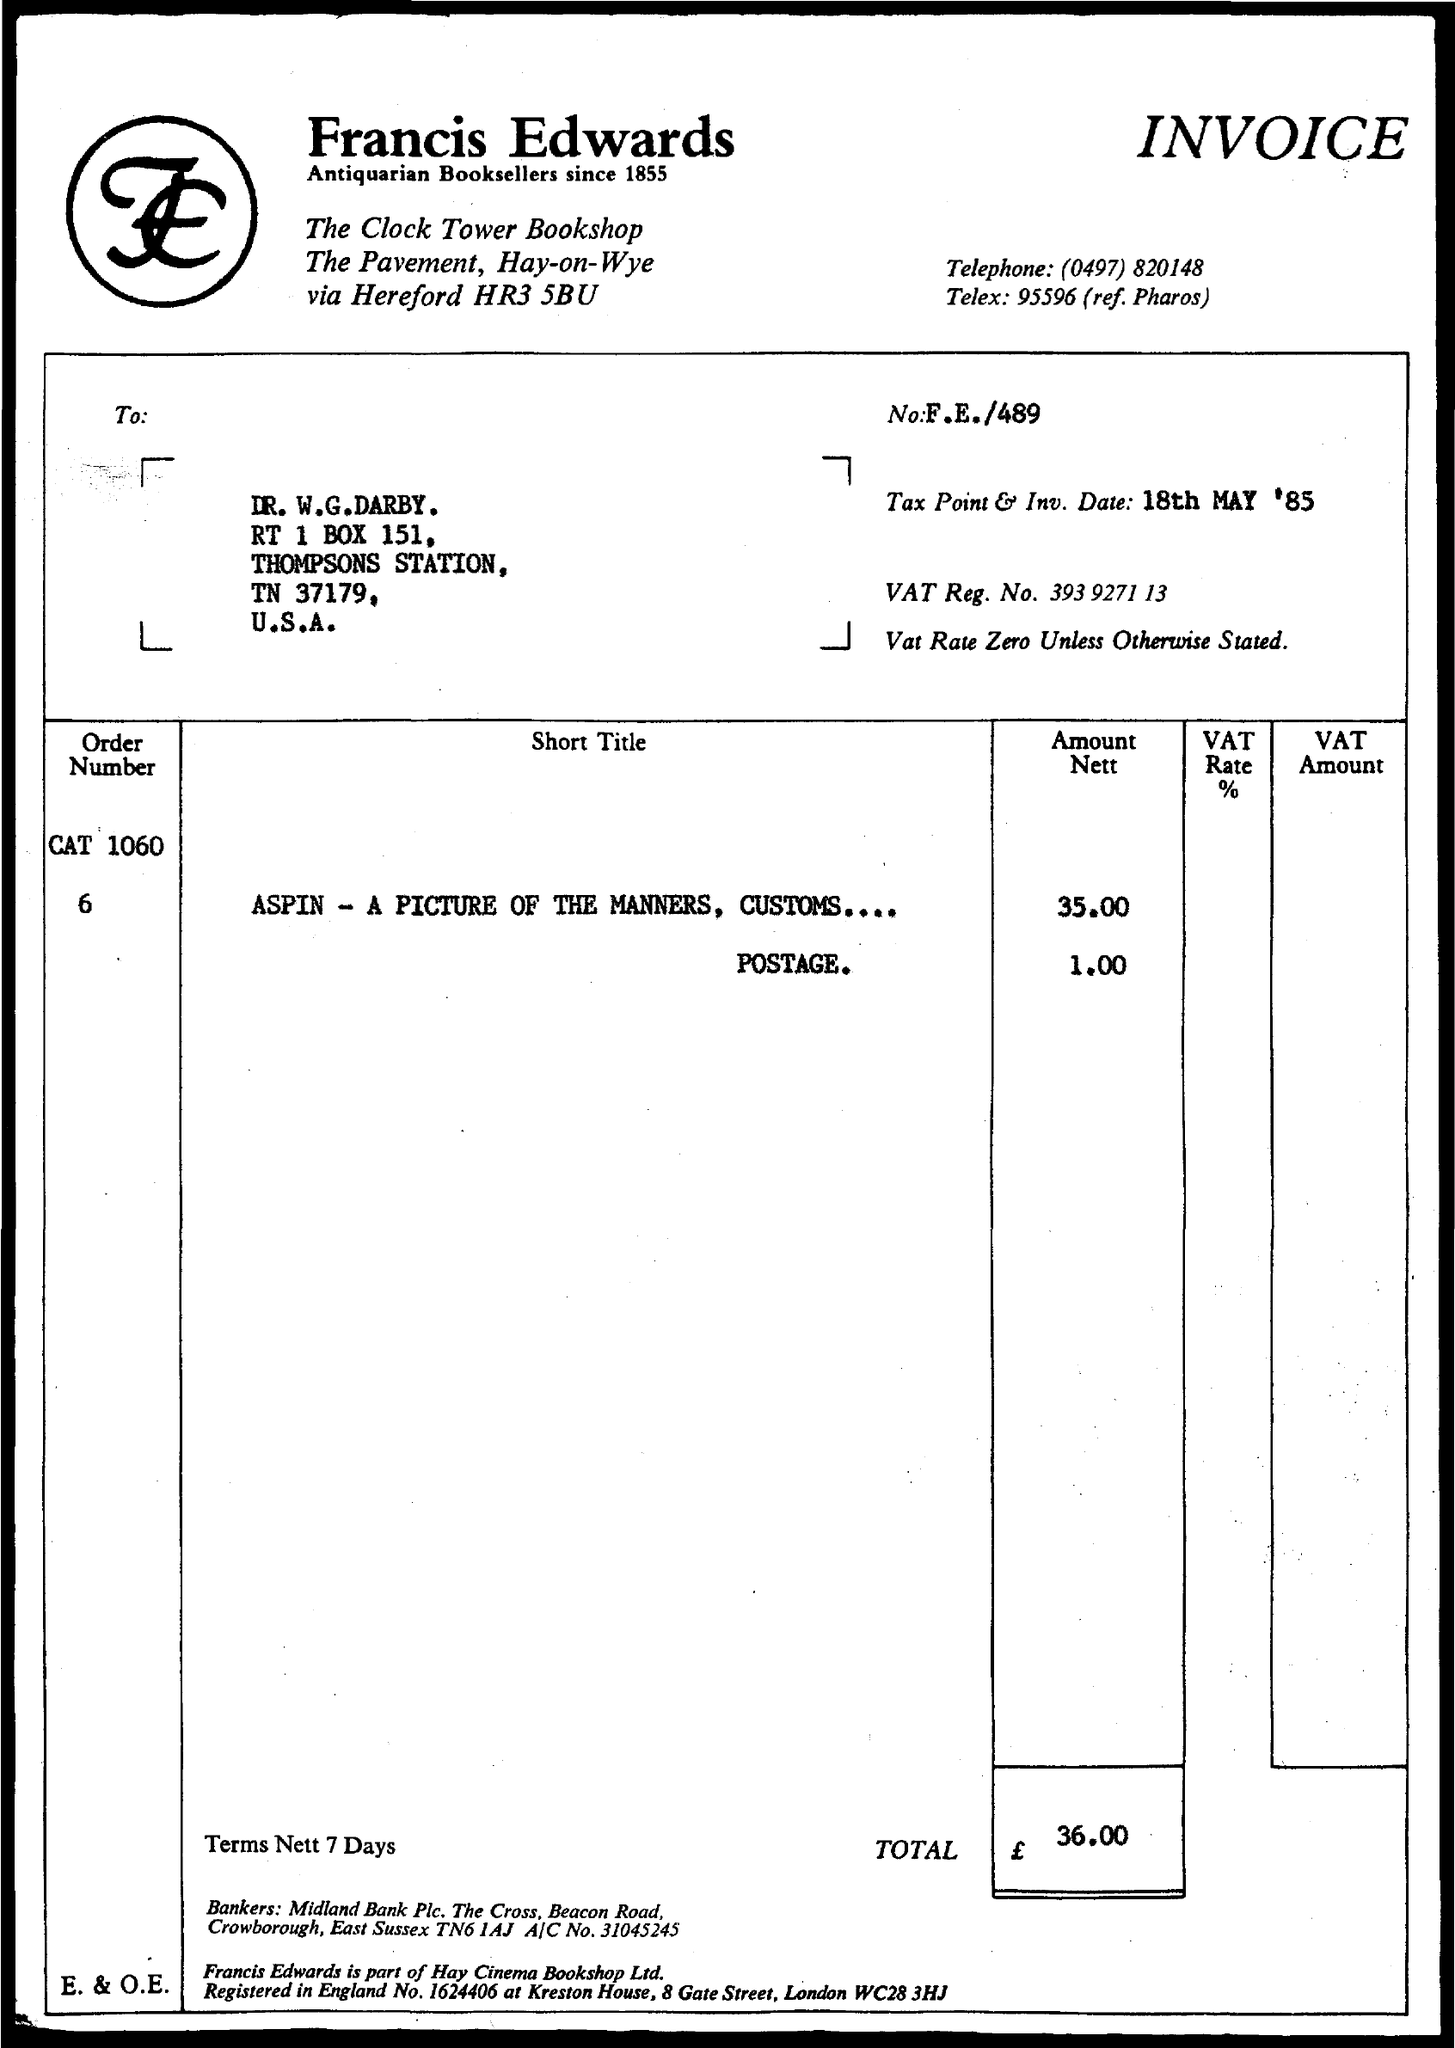What type of documentation is this?
Your answer should be very brief. INVOICE. Who are Francis Edwards?
Make the answer very short. Antiquarian Booksellers since 1855. What is the telephone number given?
Offer a terse response. (0497) 820148. What is the Tax Point & Inv. Date given?
Keep it short and to the point. 18TH MAY '85. What is the VAT Reg. No.?
Offer a terse response. 393 9271 13. What is the Vat Rate unless otherwise stated?
Offer a terse response. Zero. Which item has 35.00 as the Amount Nett?
Provide a short and direct response. ASPIN - A PICTURE OF THE MANNERS, CUSTOMS.... Which bookshop Ltd. is Francis Edwards part of?
Keep it short and to the point. Hay Cinema Bookshop Ltd. What is the name of the bank given in "bankers"?
Keep it short and to the point. Midland bank plc. 